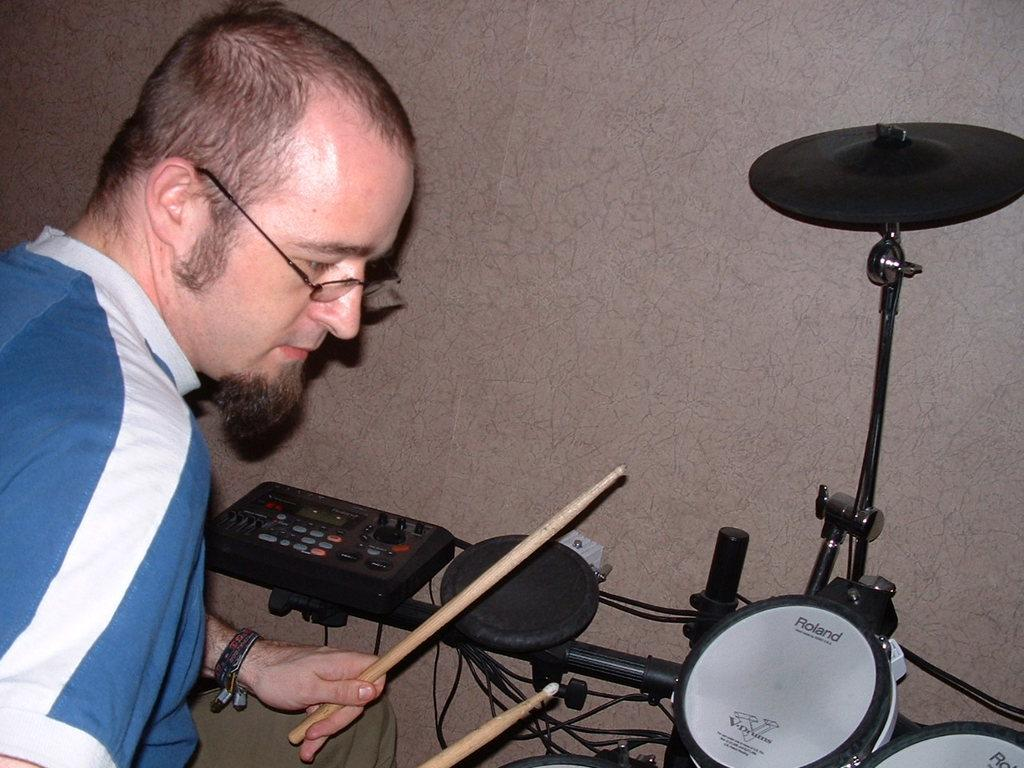What can be seen in the image related to a person? There is a person in the image. Can you describe the person's appearance? The person is wearing spectacles. What is the person holding in the image? The person is holding an object. What type of musical instrument is present in the image? There is an electronic drum in the image. What is visible in the background of the image? There is a wall visible in the image. What type of cracker is being used to play the electronic drum in the image? There is no cracker present in the image, and the person is not using a cracker to play the electronic drum. 